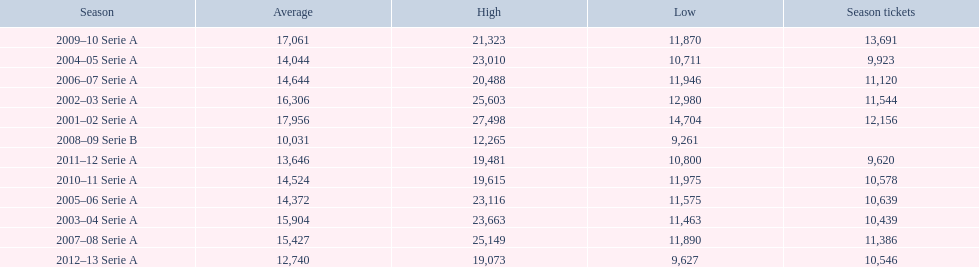What seasons were played at the stadio ennio tardini 2001–02 Serie A, 2002–03 Serie A, 2003–04 Serie A, 2004–05 Serie A, 2005–06 Serie A, 2006–07 Serie A, 2007–08 Serie A, 2008–09 Serie B, 2009–10 Serie A, 2010–11 Serie A, 2011–12 Serie A, 2012–13 Serie A. Parse the full table in json format. {'header': ['Season', 'Average', 'High', 'Low', 'Season tickets'], 'rows': [['2009–10 Serie A', '17,061', '21,323', '11,870', '13,691'], ['2004–05 Serie A', '14,044', '23,010', '10,711', '9,923'], ['2006–07 Serie A', '14,644', '20,488', '11,946', '11,120'], ['2002–03 Serie A', '16,306', '25,603', '12,980', '11,544'], ['2001–02 Serie A', '17,956', '27,498', '14,704', '12,156'], ['2008–09 Serie B', '10,031', '12,265', '9,261', ''], ['2011–12 Serie A', '13,646', '19,481', '10,800', '9,620'], ['2010–11 Serie A', '14,524', '19,615', '11,975', '10,578'], ['2005–06 Serie A', '14,372', '23,116', '11,575', '10,639'], ['2003–04 Serie A', '15,904', '23,663', '11,463', '10,439'], ['2007–08 Serie A', '15,427', '25,149', '11,890', '11,386'], ['2012–13 Serie A', '12,740', '19,073', '9,627', '10,546']]} Which of these seasons had season tickets? 2001–02 Serie A, 2002–03 Serie A, 2003–04 Serie A, 2004–05 Serie A, 2005–06 Serie A, 2006–07 Serie A, 2007–08 Serie A, 2009–10 Serie A, 2010–11 Serie A, 2011–12 Serie A, 2012–13 Serie A. How many season tickets did the 2007-08 season have? 11,386. 